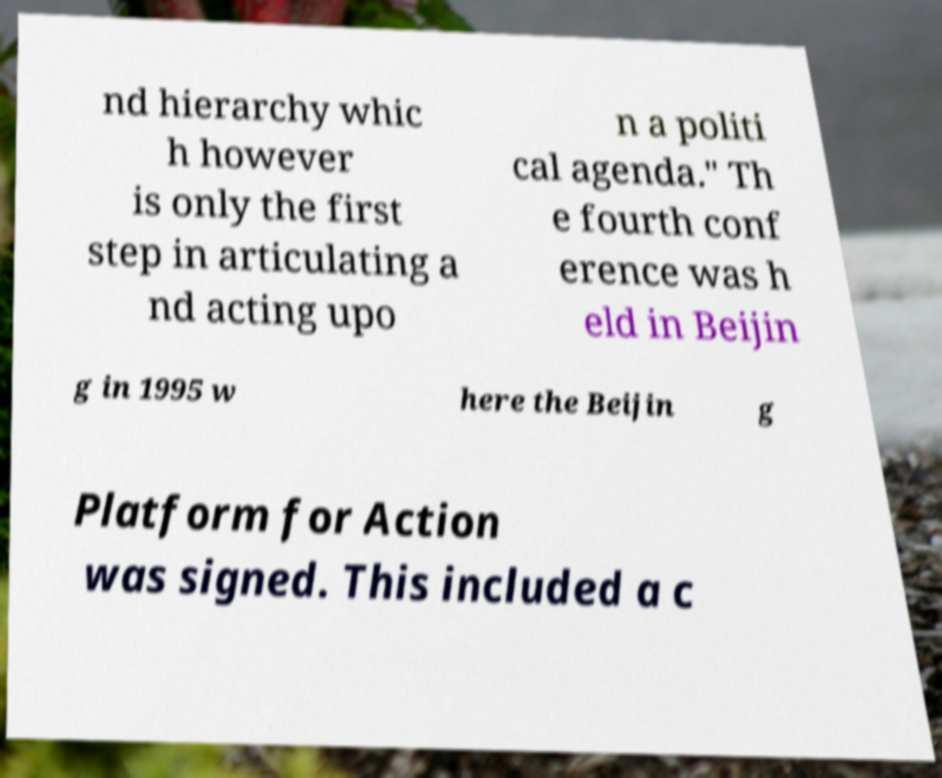Can you read and provide the text displayed in the image?This photo seems to have some interesting text. Can you extract and type it out for me? nd hierarchy whic h however is only the first step in articulating a nd acting upo n a politi cal agenda." Th e fourth conf erence was h eld in Beijin g in 1995 w here the Beijin g Platform for Action was signed. This included a c 